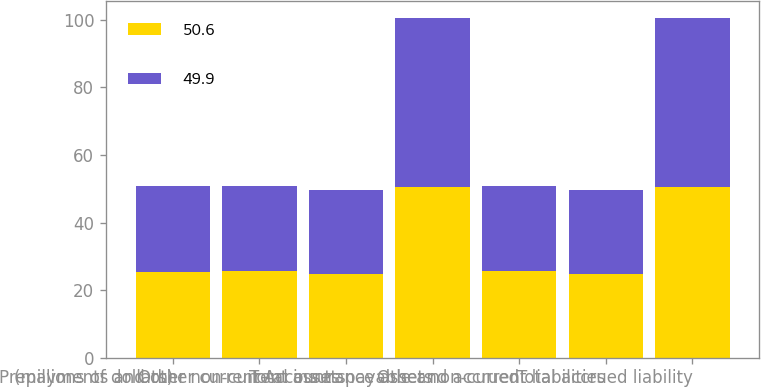<chart> <loc_0><loc_0><loc_500><loc_500><stacked_bar_chart><ecel><fcel>(millions of dollars)<fcel>Prepayments and other current<fcel>Other non-current assets<fcel>Total insurance assets<fcel>Accounts payable and accrued<fcel>Other non-current liabilities<fcel>Total accrued liability<nl><fcel>50.6<fcel>25.4<fcel>25.8<fcel>24.8<fcel>50.6<fcel>25.8<fcel>24.8<fcel>50.6<nl><fcel>49.9<fcel>25.4<fcel>24.9<fcel>25<fcel>49.9<fcel>24.9<fcel>25<fcel>49.9<nl></chart> 